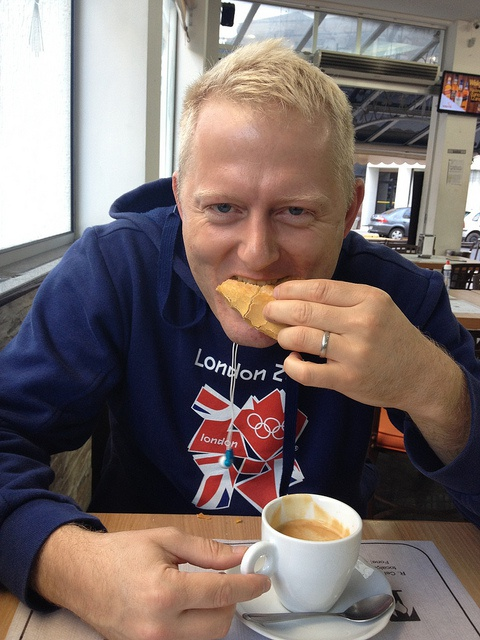Describe the objects in this image and their specific colors. I can see people in lightgray, black, gray, tan, and navy tones, dining table in lightgray, darkgray, and gray tones, cup in lightgray, darkgray, and tan tones, spoon in lightgray, gray, and black tones, and tv in lightgray, maroon, black, brown, and lavender tones in this image. 